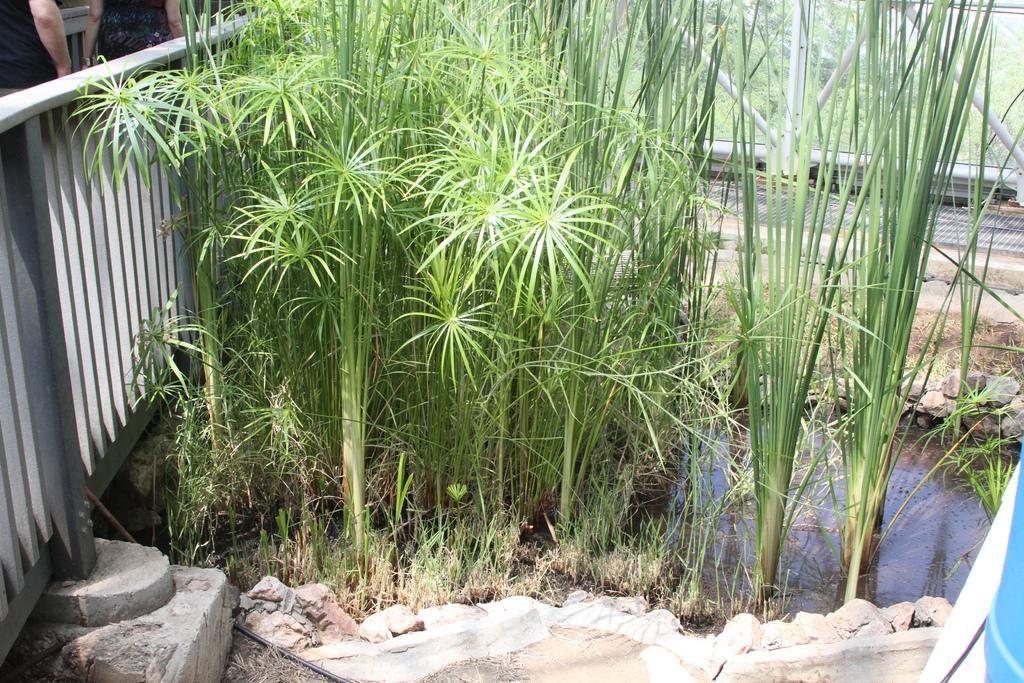How would you summarize this image in a sentence or two? In this picture I can see two persons, iron grills, plants, grass, water, and in the background there are trees. 